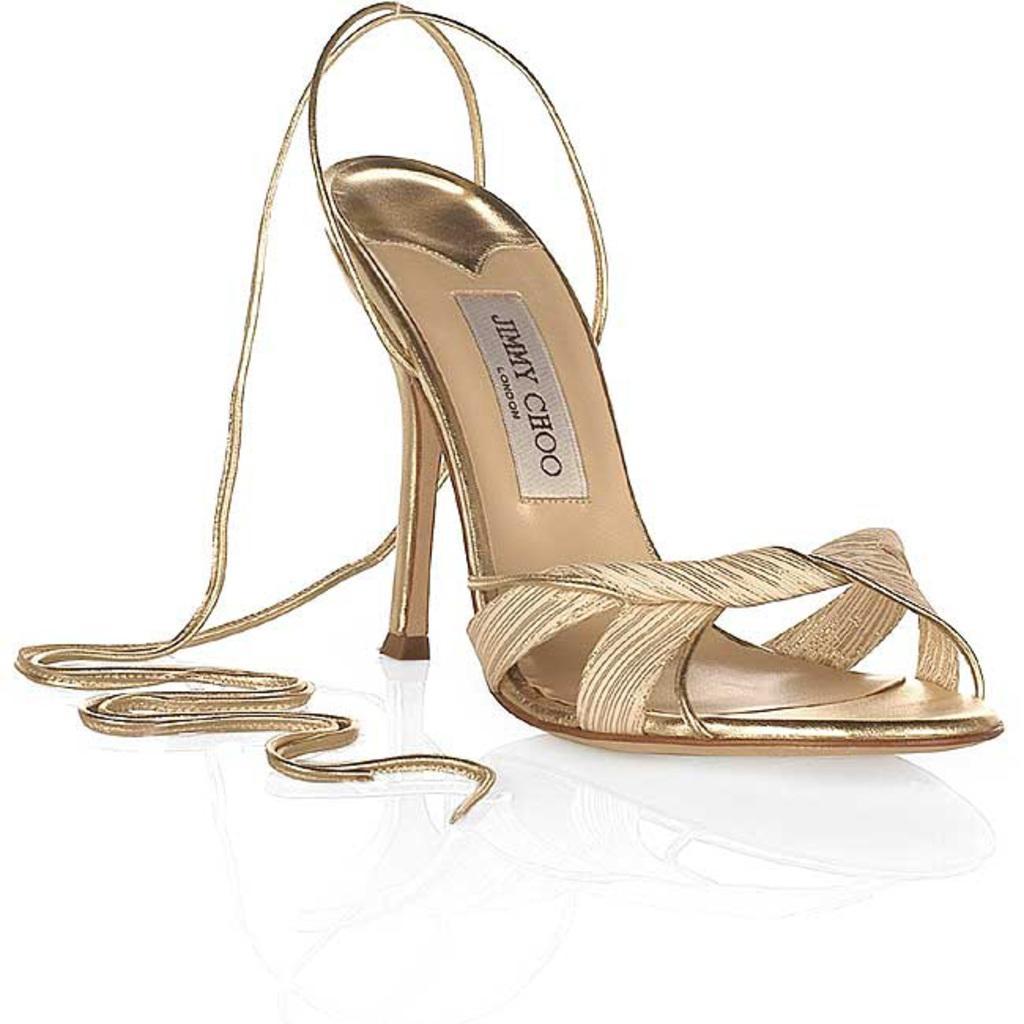In one or two sentences, can you explain what this image depicts? In this picture there is a heel of a woman which has jimmy choo written on it. 